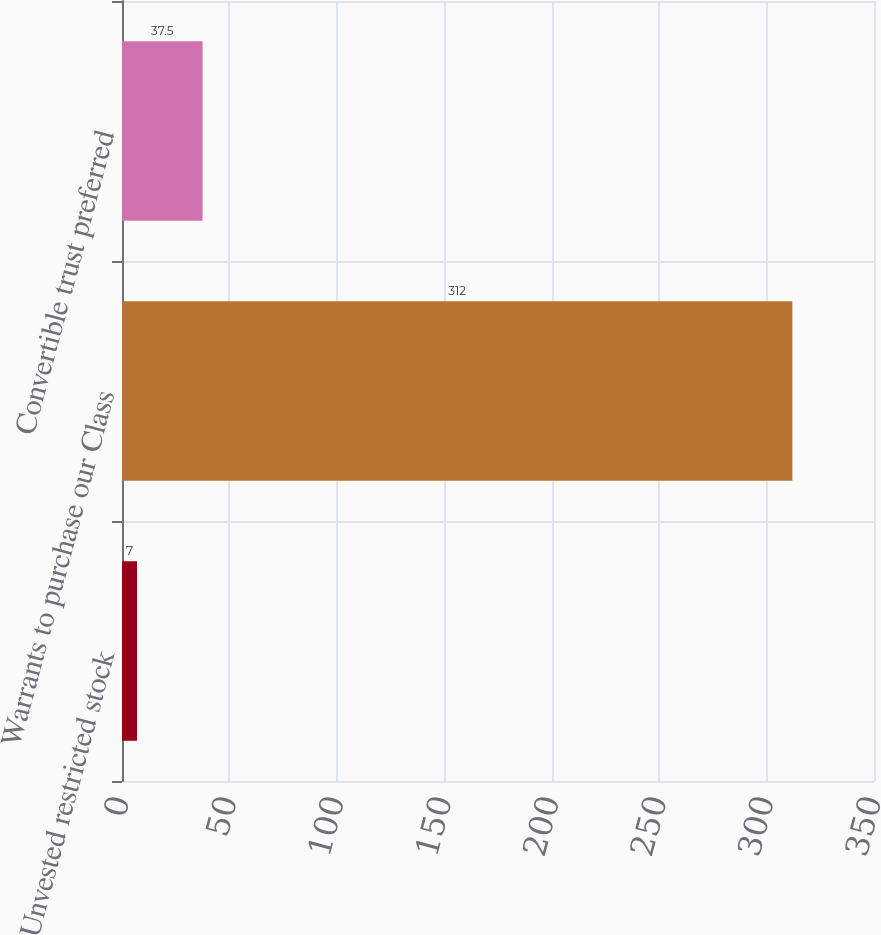<chart> <loc_0><loc_0><loc_500><loc_500><bar_chart><fcel>Unvested restricted stock<fcel>Warrants to purchase our Class<fcel>Convertible trust preferred<nl><fcel>7<fcel>312<fcel>37.5<nl></chart> 